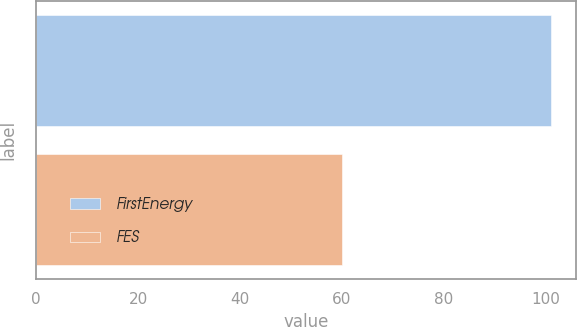Convert chart to OTSL. <chart><loc_0><loc_0><loc_500><loc_500><bar_chart><fcel>FirstEnergy<fcel>FES<nl><fcel>101<fcel>60<nl></chart> 